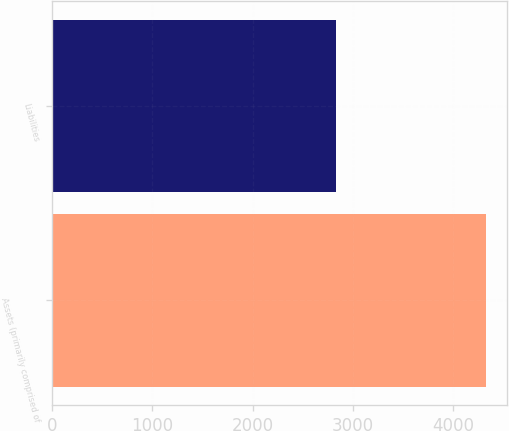Convert chart to OTSL. <chart><loc_0><loc_0><loc_500><loc_500><bar_chart><fcel>Assets (primarily comprised of<fcel>Liabilities<nl><fcel>4325<fcel>2830<nl></chart> 